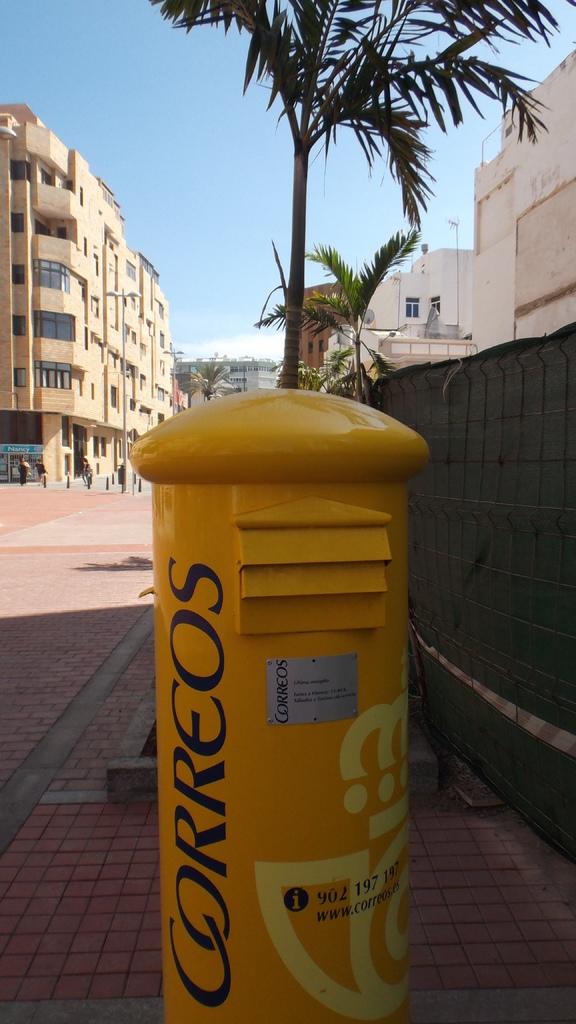What website do you visit for more information of the company labelled on the pole?
Your answer should be compact. Www.correos.es. 